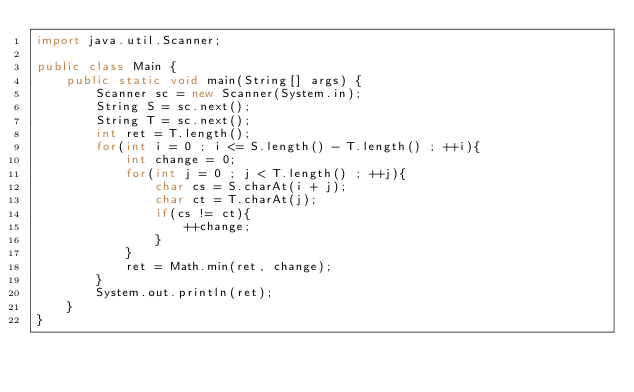<code> <loc_0><loc_0><loc_500><loc_500><_Java_>import java.util.Scanner;

public class Main {
	public static void main(String[] args) {
		Scanner sc = new Scanner(System.in);
		String S = sc.next();
		String T = sc.next();
		int ret = T.length();
		for(int i = 0 ; i <= S.length() - T.length() ; ++i){
			int change = 0;
			for(int j = 0 ; j < T.length() ; ++j){
				char cs = S.charAt(i + j);
				char ct = T.charAt(j);
				if(cs != ct){
					++change;
				}
			}
			ret = Math.min(ret, change);
		}
		System.out.println(ret);
	}
}
</code> 